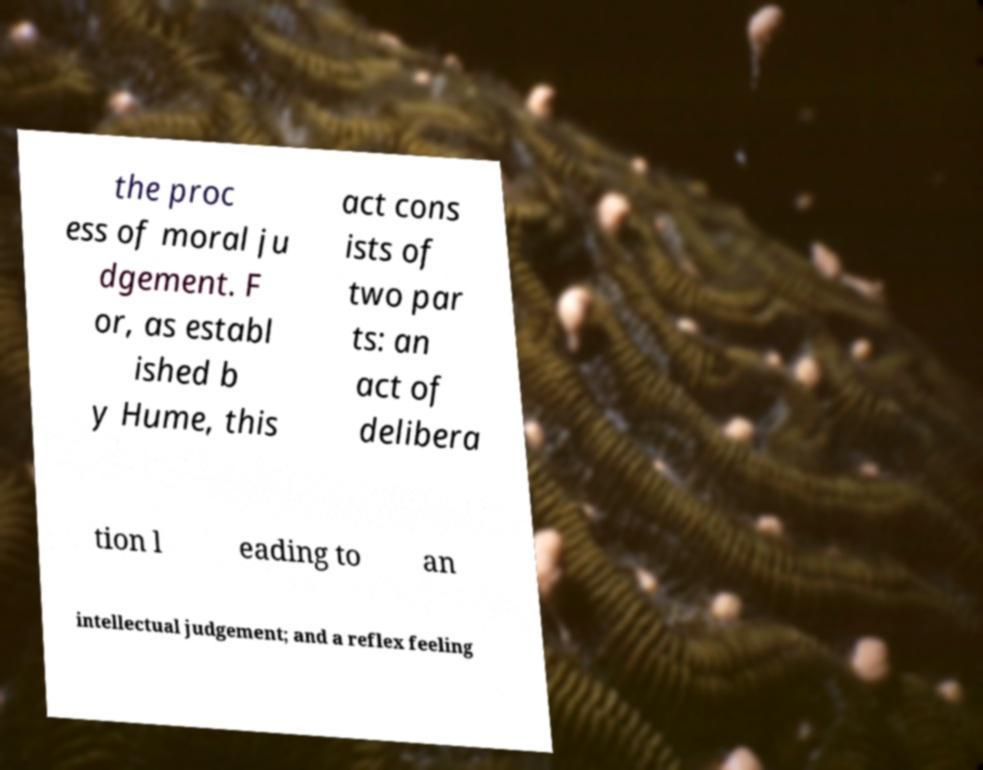I need the written content from this picture converted into text. Can you do that? the proc ess of moral ju dgement. F or, as establ ished b y Hume, this act cons ists of two par ts: an act of delibera tion l eading to an intellectual judgement; and a reflex feeling 